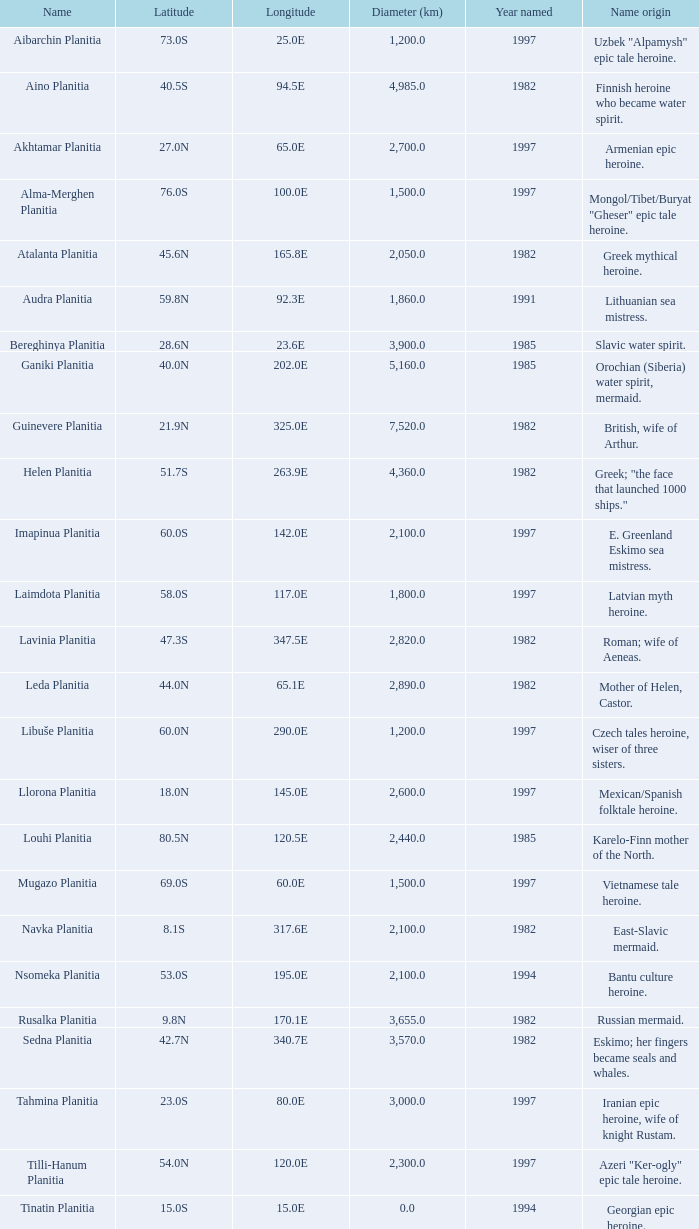0s? 3000.0. 